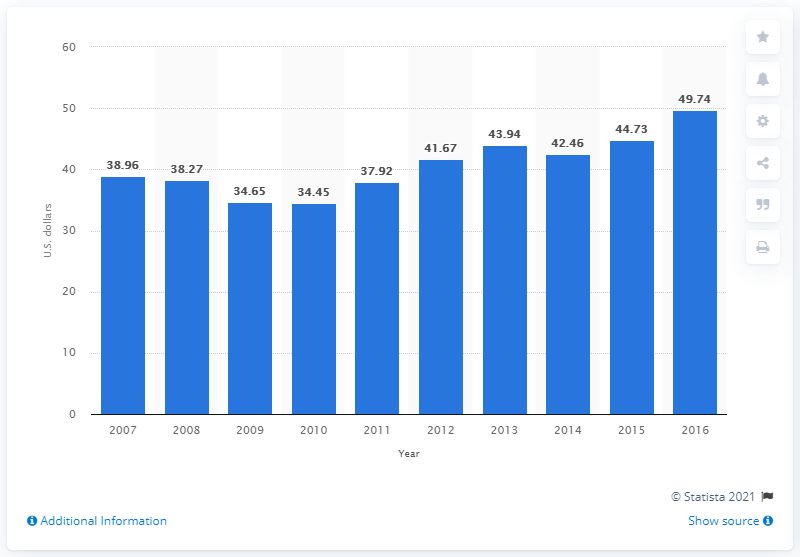Identify some key points in this picture. In 2016, the typical consumer intended to spend an average of 49.74 dollars on Valentine's Day gifts for their family members. 